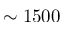Convert formula to latex. <formula><loc_0><loc_0><loc_500><loc_500>\sim 1 5 0 0</formula> 